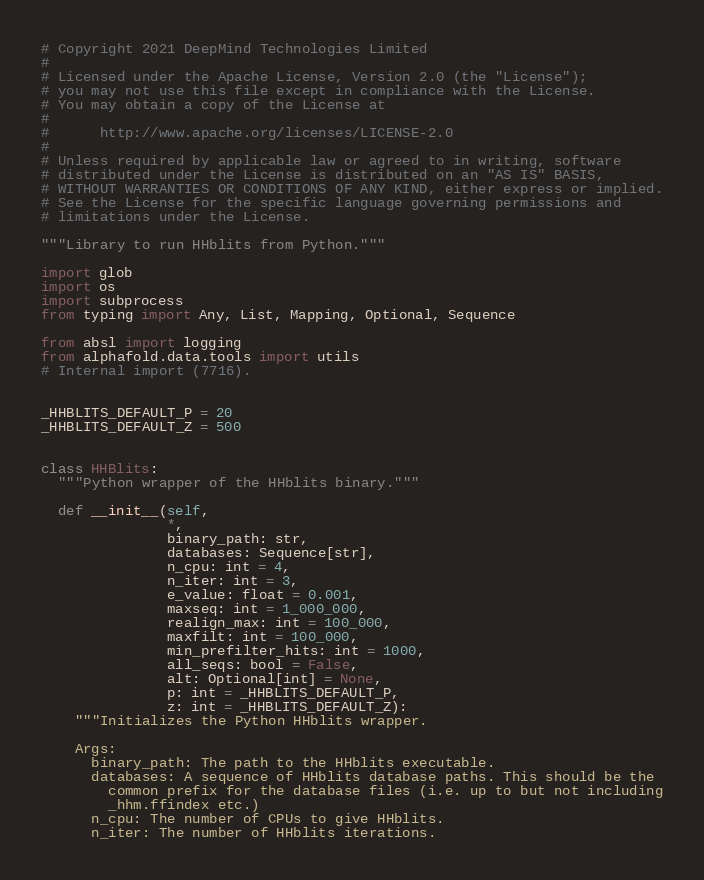<code> <loc_0><loc_0><loc_500><loc_500><_Python_># Copyright 2021 DeepMind Technologies Limited
#
# Licensed under the Apache License, Version 2.0 (the "License");
# you may not use this file except in compliance with the License.
# You may obtain a copy of the License at
#
#      http://www.apache.org/licenses/LICENSE-2.0
#
# Unless required by applicable law or agreed to in writing, software
# distributed under the License is distributed on an "AS IS" BASIS,
# WITHOUT WARRANTIES OR CONDITIONS OF ANY KIND, either express or implied.
# See the License for the specific language governing permissions and
# limitations under the License.

"""Library to run HHblits from Python."""

import glob
import os
import subprocess
from typing import Any, List, Mapping, Optional, Sequence

from absl import logging
from alphafold.data.tools import utils
# Internal import (7716).


_HHBLITS_DEFAULT_P = 20
_HHBLITS_DEFAULT_Z = 500


class HHBlits:
  """Python wrapper of the HHblits binary."""

  def __init__(self,
               *,
               binary_path: str,
               databases: Sequence[str],
               n_cpu: int = 4,
               n_iter: int = 3,
               e_value: float = 0.001,
               maxseq: int = 1_000_000,
               realign_max: int = 100_000,
               maxfilt: int = 100_000,
               min_prefilter_hits: int = 1000,
               all_seqs: bool = False,
               alt: Optional[int] = None,
               p: int = _HHBLITS_DEFAULT_P,
               z: int = _HHBLITS_DEFAULT_Z):
    """Initializes the Python HHblits wrapper.

    Args:
      binary_path: The path to the HHblits executable.
      databases: A sequence of HHblits database paths. This should be the
        common prefix for the database files (i.e. up to but not including
        _hhm.ffindex etc.)
      n_cpu: The number of CPUs to give HHblits.
      n_iter: The number of HHblits iterations.</code> 